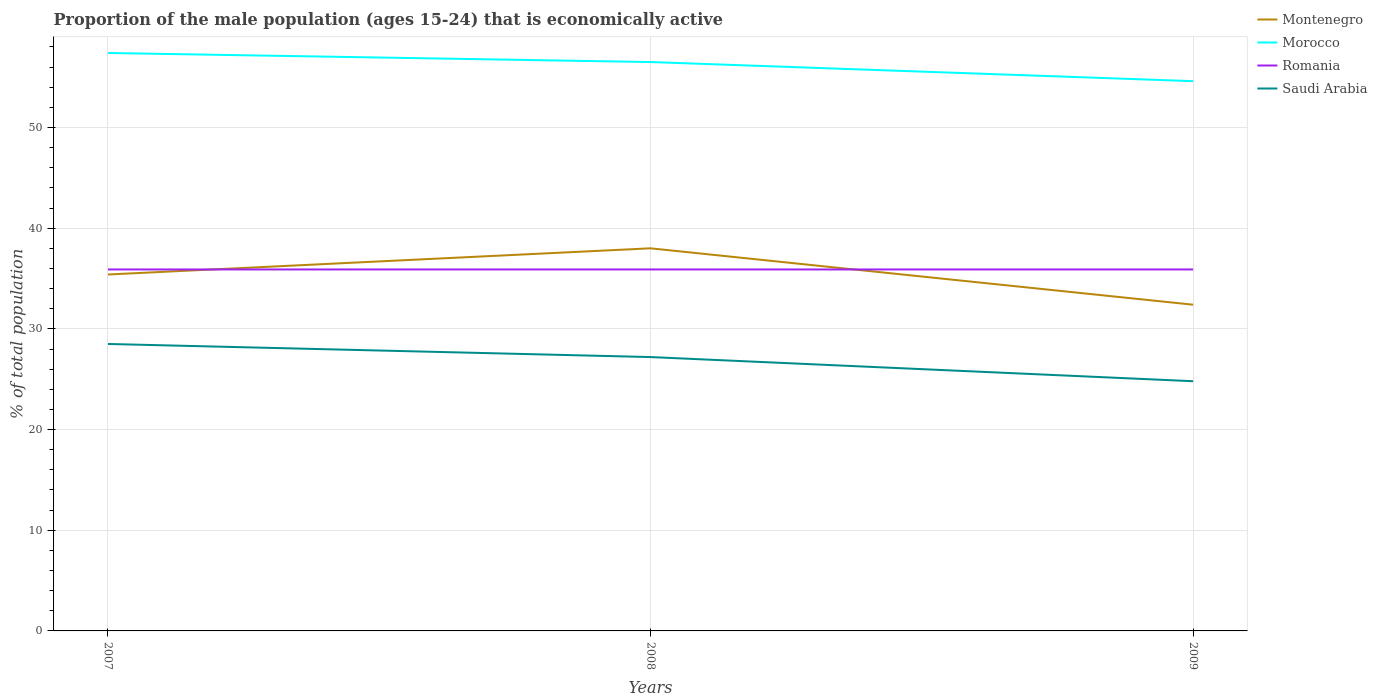How many different coloured lines are there?
Offer a terse response. 4. Across all years, what is the maximum proportion of the male population that is economically active in Romania?
Your answer should be compact. 35.9. What is the total proportion of the male population that is economically active in Morocco in the graph?
Ensure brevity in your answer.  0.9. What is the difference between the highest and the second highest proportion of the male population that is economically active in Romania?
Your answer should be compact. 0. What is the difference between the highest and the lowest proportion of the male population that is economically active in Saudi Arabia?
Provide a short and direct response. 2. How many years are there in the graph?
Offer a terse response. 3. Are the values on the major ticks of Y-axis written in scientific E-notation?
Your response must be concise. No. How are the legend labels stacked?
Offer a very short reply. Vertical. What is the title of the graph?
Your answer should be very brief. Proportion of the male population (ages 15-24) that is economically active. Does "St. Martin (French part)" appear as one of the legend labels in the graph?
Your answer should be compact. No. What is the label or title of the Y-axis?
Your answer should be very brief. % of total population. What is the % of total population of Montenegro in 2007?
Offer a very short reply. 35.4. What is the % of total population of Morocco in 2007?
Your response must be concise. 57.4. What is the % of total population of Romania in 2007?
Offer a very short reply. 35.9. What is the % of total population in Saudi Arabia in 2007?
Your answer should be very brief. 28.5. What is the % of total population in Montenegro in 2008?
Your answer should be compact. 38. What is the % of total population of Morocco in 2008?
Keep it short and to the point. 56.5. What is the % of total population in Romania in 2008?
Keep it short and to the point. 35.9. What is the % of total population in Saudi Arabia in 2008?
Provide a succinct answer. 27.2. What is the % of total population in Montenegro in 2009?
Offer a terse response. 32.4. What is the % of total population in Morocco in 2009?
Your response must be concise. 54.6. What is the % of total population of Romania in 2009?
Give a very brief answer. 35.9. What is the % of total population of Saudi Arabia in 2009?
Give a very brief answer. 24.8. Across all years, what is the maximum % of total population in Montenegro?
Offer a very short reply. 38. Across all years, what is the maximum % of total population in Morocco?
Offer a terse response. 57.4. Across all years, what is the maximum % of total population of Romania?
Your answer should be very brief. 35.9. Across all years, what is the maximum % of total population of Saudi Arabia?
Give a very brief answer. 28.5. Across all years, what is the minimum % of total population in Montenegro?
Ensure brevity in your answer.  32.4. Across all years, what is the minimum % of total population of Morocco?
Keep it short and to the point. 54.6. Across all years, what is the minimum % of total population in Romania?
Your answer should be very brief. 35.9. Across all years, what is the minimum % of total population in Saudi Arabia?
Provide a succinct answer. 24.8. What is the total % of total population in Montenegro in the graph?
Ensure brevity in your answer.  105.8. What is the total % of total population in Morocco in the graph?
Make the answer very short. 168.5. What is the total % of total population of Romania in the graph?
Offer a terse response. 107.7. What is the total % of total population in Saudi Arabia in the graph?
Your response must be concise. 80.5. What is the difference between the % of total population in Montenegro in 2007 and that in 2008?
Provide a short and direct response. -2.6. What is the difference between the % of total population of Romania in 2007 and that in 2008?
Provide a succinct answer. 0. What is the difference between the % of total population of Montenegro in 2007 and that in 2009?
Make the answer very short. 3. What is the difference between the % of total population in Morocco in 2007 and that in 2009?
Your answer should be very brief. 2.8. What is the difference between the % of total population of Saudi Arabia in 2007 and that in 2009?
Offer a very short reply. 3.7. What is the difference between the % of total population of Saudi Arabia in 2008 and that in 2009?
Ensure brevity in your answer.  2.4. What is the difference between the % of total population of Montenegro in 2007 and the % of total population of Morocco in 2008?
Your answer should be compact. -21.1. What is the difference between the % of total population in Montenegro in 2007 and the % of total population in Romania in 2008?
Offer a terse response. -0.5. What is the difference between the % of total population of Montenegro in 2007 and the % of total population of Saudi Arabia in 2008?
Your response must be concise. 8.2. What is the difference between the % of total population of Morocco in 2007 and the % of total population of Saudi Arabia in 2008?
Ensure brevity in your answer.  30.2. What is the difference between the % of total population in Montenegro in 2007 and the % of total population in Morocco in 2009?
Provide a succinct answer. -19.2. What is the difference between the % of total population of Montenegro in 2007 and the % of total population of Romania in 2009?
Offer a terse response. -0.5. What is the difference between the % of total population of Morocco in 2007 and the % of total population of Romania in 2009?
Offer a very short reply. 21.5. What is the difference between the % of total population of Morocco in 2007 and the % of total population of Saudi Arabia in 2009?
Offer a terse response. 32.6. What is the difference between the % of total population in Montenegro in 2008 and the % of total population in Morocco in 2009?
Provide a short and direct response. -16.6. What is the difference between the % of total population of Morocco in 2008 and the % of total population of Romania in 2009?
Your answer should be compact. 20.6. What is the difference between the % of total population in Morocco in 2008 and the % of total population in Saudi Arabia in 2009?
Your response must be concise. 31.7. What is the average % of total population in Montenegro per year?
Make the answer very short. 35.27. What is the average % of total population in Morocco per year?
Offer a very short reply. 56.17. What is the average % of total population of Romania per year?
Your answer should be compact. 35.9. What is the average % of total population in Saudi Arabia per year?
Offer a very short reply. 26.83. In the year 2007, what is the difference between the % of total population in Montenegro and % of total population in Romania?
Provide a succinct answer. -0.5. In the year 2007, what is the difference between the % of total population of Morocco and % of total population of Romania?
Offer a terse response. 21.5. In the year 2007, what is the difference between the % of total population of Morocco and % of total population of Saudi Arabia?
Your answer should be very brief. 28.9. In the year 2007, what is the difference between the % of total population of Romania and % of total population of Saudi Arabia?
Offer a terse response. 7.4. In the year 2008, what is the difference between the % of total population in Montenegro and % of total population in Morocco?
Your response must be concise. -18.5. In the year 2008, what is the difference between the % of total population in Montenegro and % of total population in Romania?
Your answer should be compact. 2.1. In the year 2008, what is the difference between the % of total population of Morocco and % of total population of Romania?
Offer a terse response. 20.6. In the year 2008, what is the difference between the % of total population of Morocco and % of total population of Saudi Arabia?
Your answer should be very brief. 29.3. In the year 2009, what is the difference between the % of total population in Montenegro and % of total population in Morocco?
Make the answer very short. -22.2. In the year 2009, what is the difference between the % of total population of Montenegro and % of total population of Saudi Arabia?
Offer a very short reply. 7.6. In the year 2009, what is the difference between the % of total population of Morocco and % of total population of Saudi Arabia?
Give a very brief answer. 29.8. In the year 2009, what is the difference between the % of total population of Romania and % of total population of Saudi Arabia?
Offer a terse response. 11.1. What is the ratio of the % of total population in Montenegro in 2007 to that in 2008?
Provide a succinct answer. 0.93. What is the ratio of the % of total population of Morocco in 2007 to that in 2008?
Your answer should be very brief. 1.02. What is the ratio of the % of total population of Saudi Arabia in 2007 to that in 2008?
Make the answer very short. 1.05. What is the ratio of the % of total population in Montenegro in 2007 to that in 2009?
Offer a terse response. 1.09. What is the ratio of the % of total population in Morocco in 2007 to that in 2009?
Give a very brief answer. 1.05. What is the ratio of the % of total population in Romania in 2007 to that in 2009?
Provide a succinct answer. 1. What is the ratio of the % of total population in Saudi Arabia in 2007 to that in 2009?
Provide a short and direct response. 1.15. What is the ratio of the % of total population of Montenegro in 2008 to that in 2009?
Offer a very short reply. 1.17. What is the ratio of the % of total population in Morocco in 2008 to that in 2009?
Keep it short and to the point. 1.03. What is the ratio of the % of total population in Romania in 2008 to that in 2009?
Ensure brevity in your answer.  1. What is the ratio of the % of total population of Saudi Arabia in 2008 to that in 2009?
Offer a terse response. 1.1. What is the difference between the highest and the second highest % of total population of Montenegro?
Offer a very short reply. 2.6. What is the difference between the highest and the second highest % of total population of Morocco?
Keep it short and to the point. 0.9. What is the difference between the highest and the second highest % of total population of Romania?
Your response must be concise. 0. What is the difference between the highest and the lowest % of total population in Montenegro?
Keep it short and to the point. 5.6. 